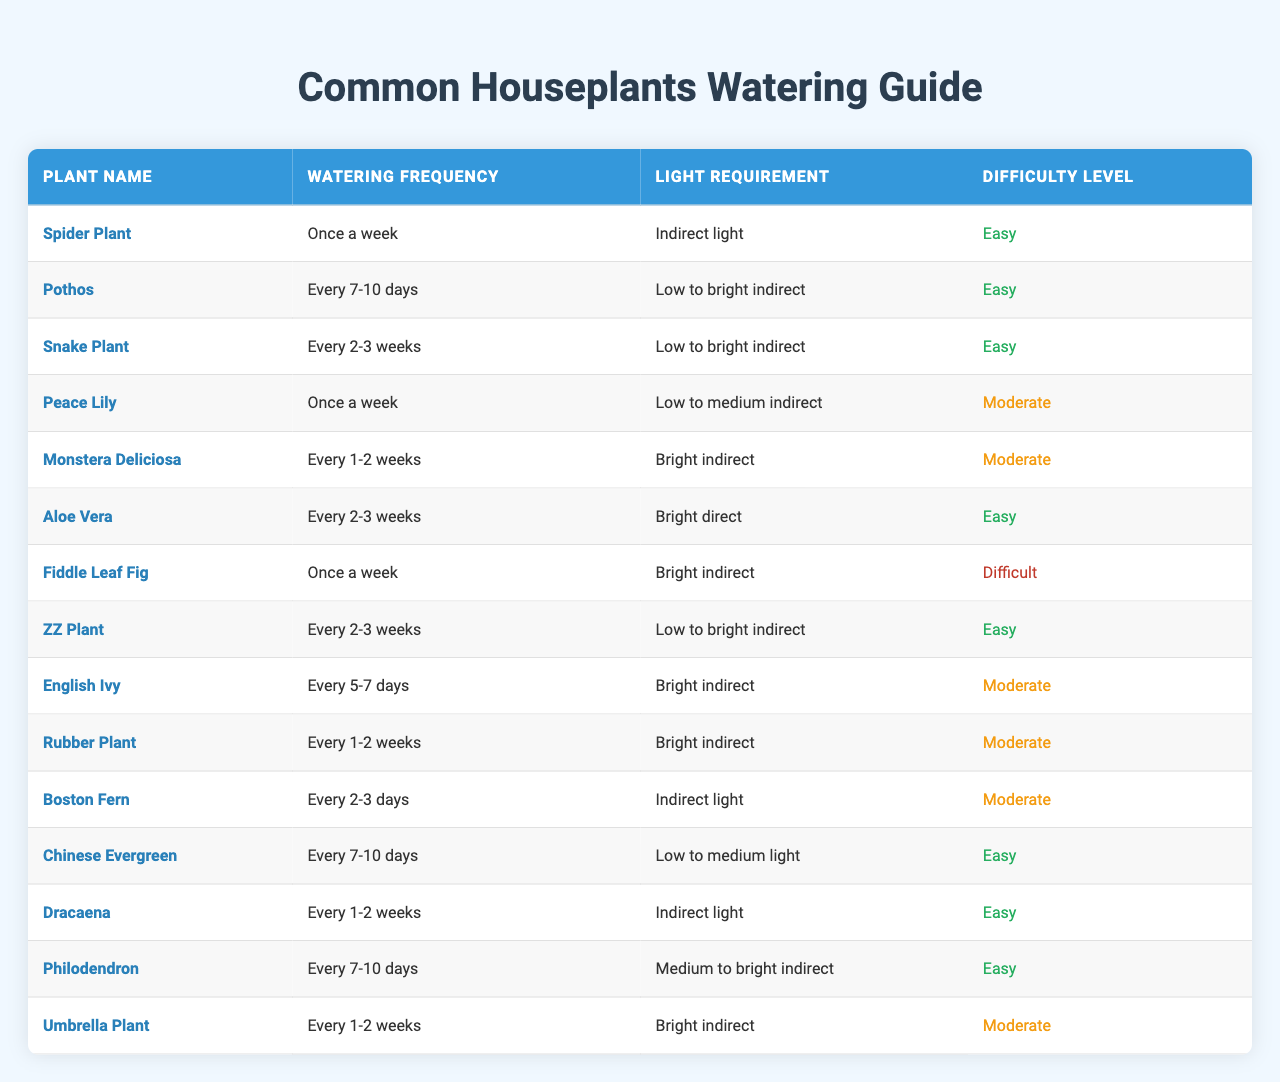What is the watering frequency for a Spider Plant? The table lists the watering frequency for each plant, and for the Spider Plant, it specifically states "Once a week".
Answer: Once a week How often should you water a Peace Lily? In the table, the watering frequency for a Peace Lily is indicated as "Once a week".
Answer: Once a week Which plant requires the least amount of water based on frequency? The plant with the longest watering interval is the Snake Plant, which needs to be watered every 2-3 weeks; compared to others, this indicates it requires the least amount of water.
Answer: Snake Plant Is the Monstera Deliciosa difficult to care for? The table notes that the Monstera Deliciosa has a difficulty level of "Moderate", indicating it's not the easiest plant to care for.
Answer: Yes How many plants need to be watered every 1-2 weeks? In the table, there are three plants listed with a watering frequency of every 1-2 weeks: Monstera Deliciosa, Rubber Plant, and Umbrella Plant. This is a simple count of those specific entries.
Answer: Three What is the average watering frequency for plants classified as easy? The easy plants and their watering frequencies are: Spider Plant (Once a week), Pothos (Every 7-10 days), Aloe Vera (Every 2-3 weeks), ZZ Plant (Every 2-3 weeks), Chinese Evergreen (Every 7-10 days), Dracaena (Every 1-2 weeks), and Philodendron (Every 7-10 days). The approximate average watering frequency would be about every 5-8 days, factoring in the weekly and biweekly averages.
Answer: Every 5-8 days Does any plant require watering more frequently than every 5 days? The Boston Fern is noted in the table to require watering every 2-3 days, which is more frequent than every 5 days, confirming that there is at least one plant that fits this criterion.
Answer: Yes Which plants require bright indirect light? The plants listed in the table that need bright indirect light are: Fiddle Leaf Fig, Monstera Deliciosa, Rubber Plant, and Umbrella Plant. By checking the light requirement column, we can find these plants.
Answer: Four If you wanted to create a low-maintenance indoor garden with easy care plants, which two options would you choose based on watering frequency? You would choose the Spider Plant, which needs watering once a week, and ZZ Plant or Aloe Vera, both of which only require watering every 2-3 weeks. These selections are based on their easy difficulty level and lower watering frequency.
Answer: Spider Plant and ZZ Plant Can the Boston Fern survive in indirect light conditions? The table specifies that the Boston Fern grows under indirect light; therefore, it can survive in such conditions.
Answer: Yes 